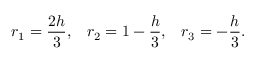<formula> <loc_0><loc_0><loc_500><loc_500>r _ { 1 } = \frac { 2 h } { 3 } , \, r _ { 2 } = 1 - \frac { h } { 3 } , \, r _ { 3 } = - \frac { h } { 3 } .</formula> 